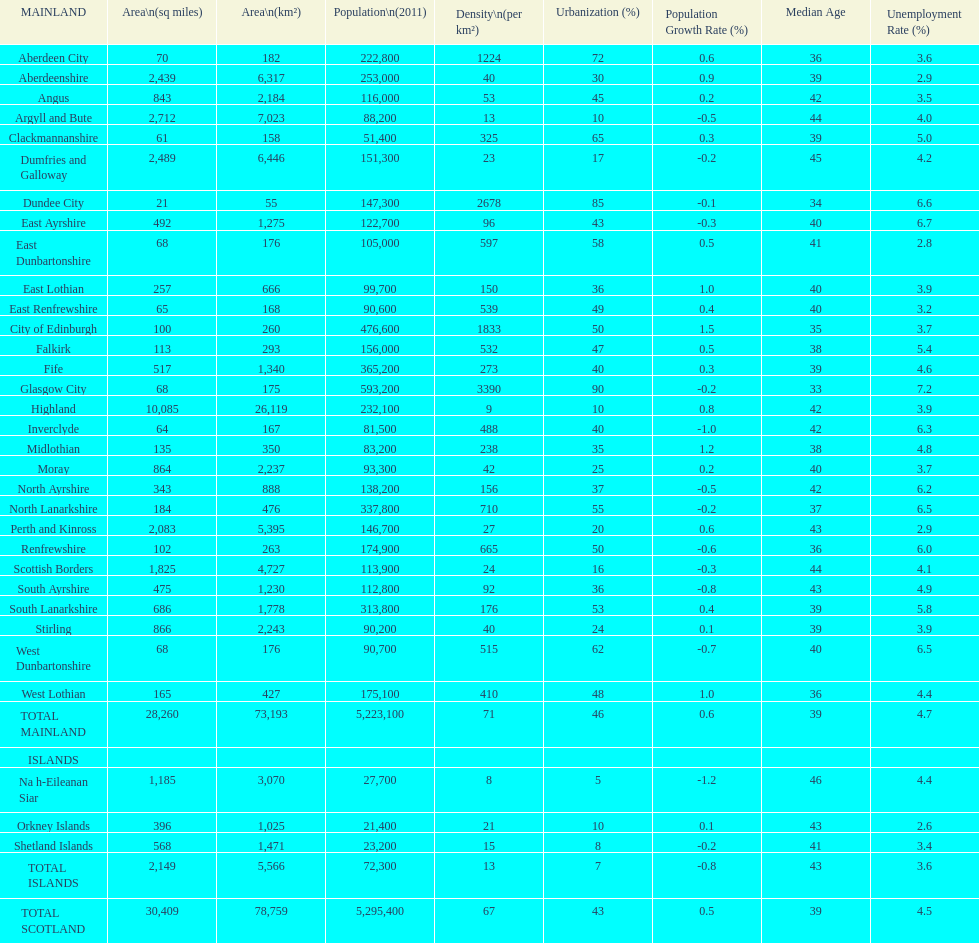What is the average population density in mainland cities? 71. 